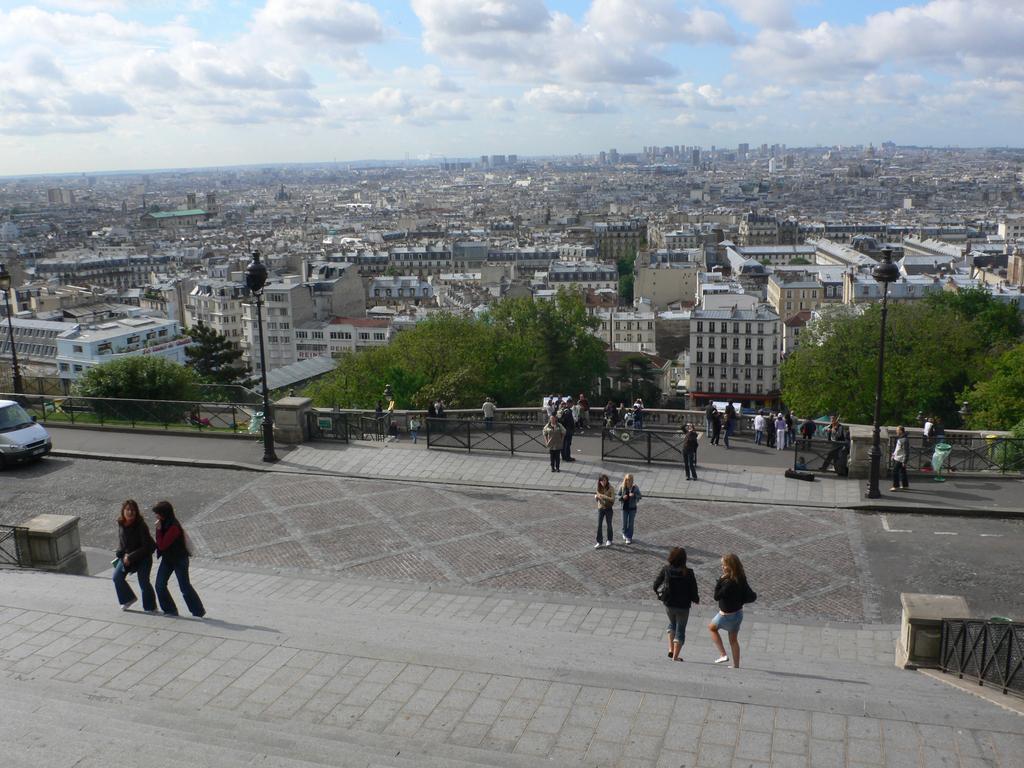In one or two sentences, can you explain what this image depicts? In this image, we can see some people walking, there is a car on the left side, we can see the fence, there are some places, we can see some green trees and there are some buildings, at the top we can see the sky and some clouds. 